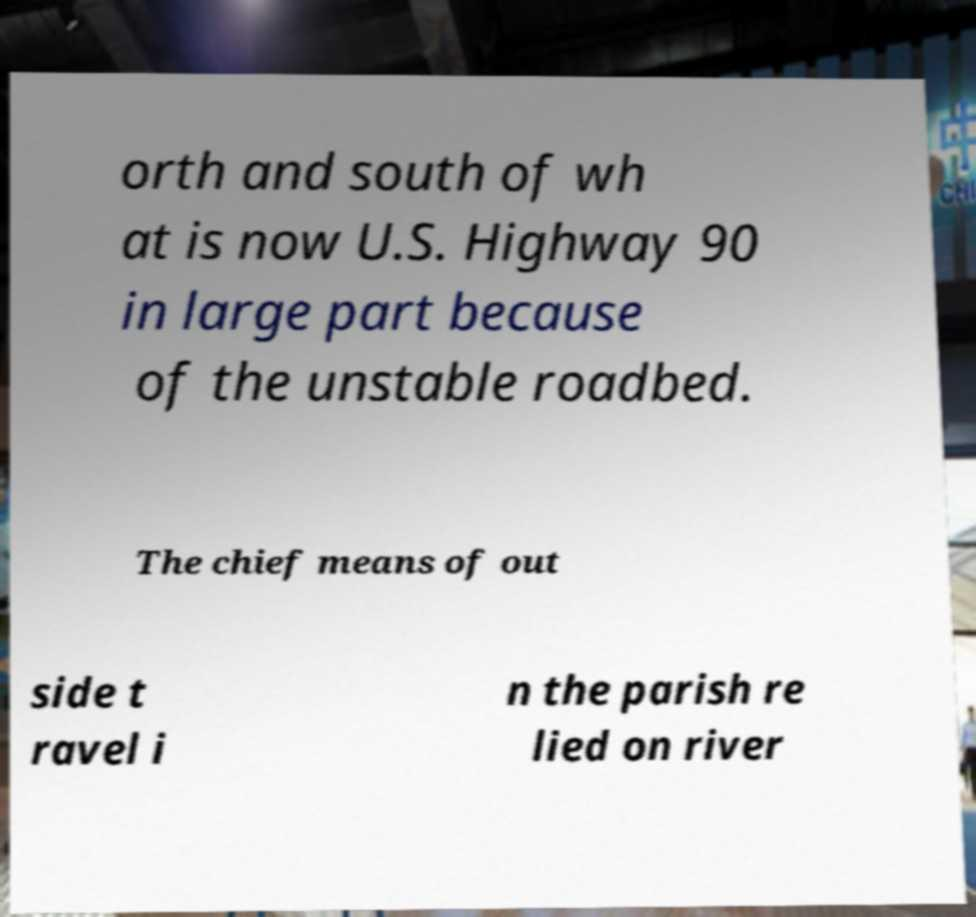Please identify and transcribe the text found in this image. orth and south of wh at is now U.S. Highway 90 in large part because of the unstable roadbed. The chief means of out side t ravel i n the parish re lied on river 